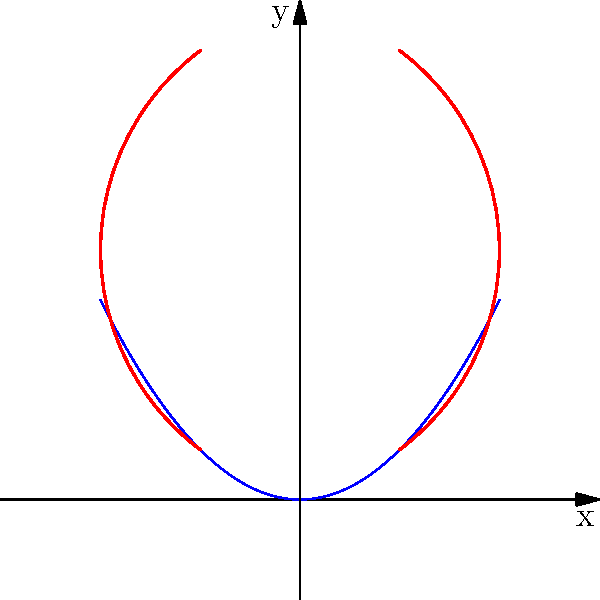In the context of Art Nouveau's emphasis on organic, flowing forms, consider the parabola $f(x) = \frac{1}{2}x^2$ and the decorative curves shown in the coordinate system. How does the concept of reflection manifest in this composition, and what is the equation of the line of symmetry for the parabola? To answer this question, let's analyze the composition step-by-step:

1. The parabola $f(x) = \frac{1}{2}x^2$ is symmetrical about the y-axis. This is evident from its equation and the graph.

2. The line of symmetry for this parabola is the y-axis, which has the equation $x = 0$.

3. The red decorative curves on either side of the parabola are reflections of each other across the y-axis. This mirrors the symmetry found in many Art Nouveau designs.

4. In Art Nouveau, symmetry often coexists with asymmetry. Here, while the overall composition is symmetrical, the individual curves are asymmetrical, creating a balance between order and organic flow.

5. The reflection of the decorative curves can be described mathematically as a transformation. If $(x, y)$ is a point on the right curve, its reflection on the left curve would be $(-x, y)$.

6. This composition demonstrates how mathematical concepts like reflection and symmetry can be used to create aesthetically pleasing designs, a principle often employed in Art Nouveau.

The line of symmetry for the parabola, which is also the axis of reflection for the decorative curves, is the y-axis with the equation $x = 0$.
Answer: $x = 0$ 